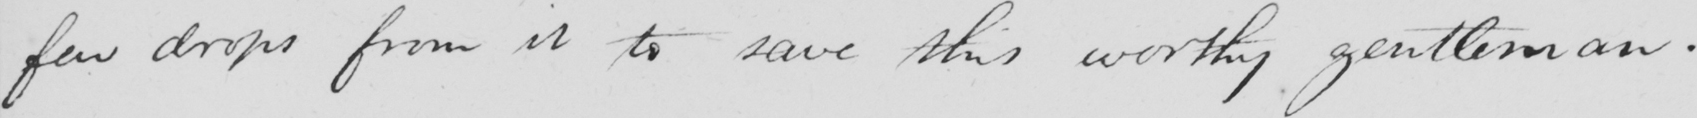Please transcribe the handwritten text in this image. few drops from it to save this worthy gentleman. 